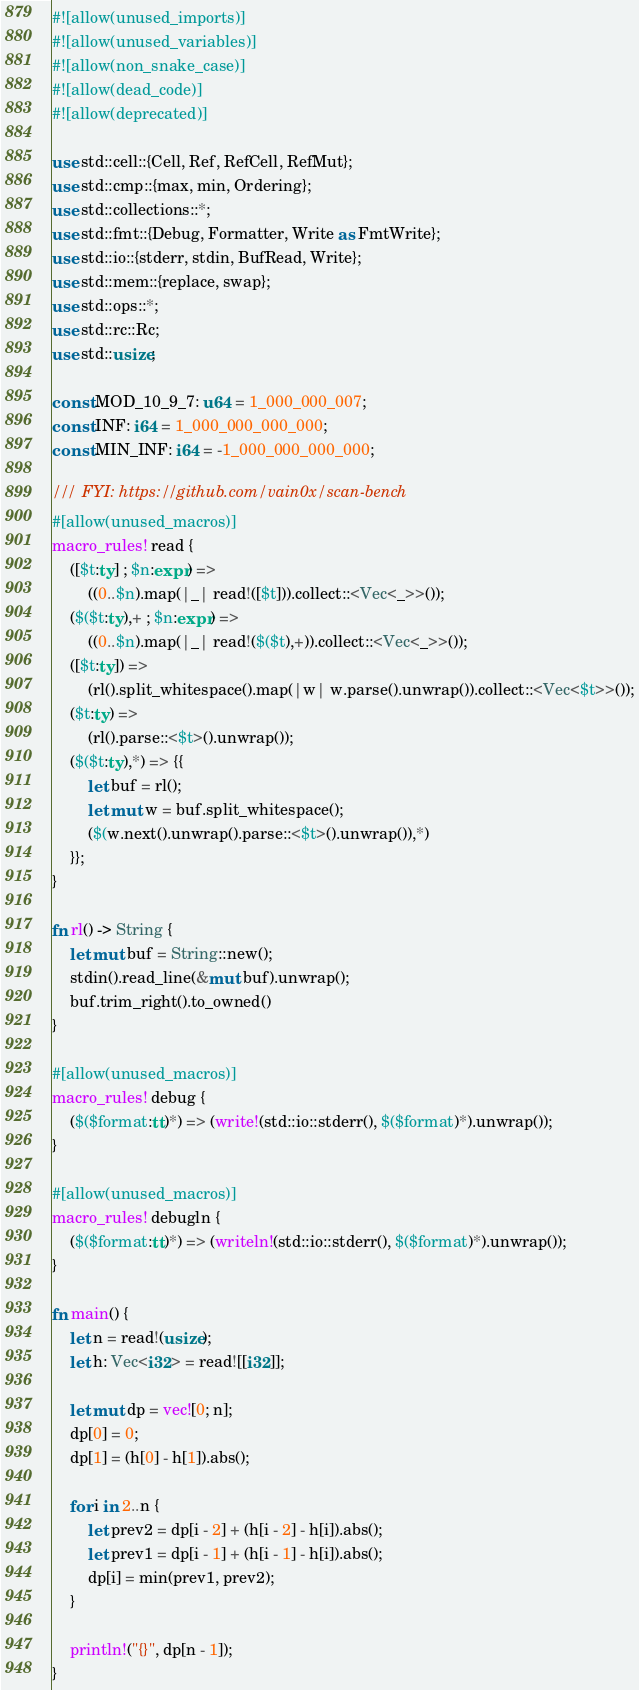<code> <loc_0><loc_0><loc_500><loc_500><_Rust_>#![allow(unused_imports)]
#![allow(unused_variables)]
#![allow(non_snake_case)]
#![allow(dead_code)]
#![allow(deprecated)]

use std::cell::{Cell, Ref, RefCell, RefMut};
use std::cmp::{max, min, Ordering};
use std::collections::*;
use std::fmt::{Debug, Formatter, Write as FmtWrite};
use std::io::{stderr, stdin, BufRead, Write};
use std::mem::{replace, swap};
use std::ops::*;
use std::rc::Rc;
use std::usize;

const MOD_10_9_7: u64 = 1_000_000_007;
const INF: i64 = 1_000_000_000_000;
const MIN_INF: i64 = -1_000_000_000_000;

/// FYI: https://github.com/vain0x/scan-bench
#[allow(unused_macros)]
macro_rules! read {
    ([$t:ty] ; $n:expr) =>
        ((0..$n).map(|_| read!([$t])).collect::<Vec<_>>());
    ($($t:ty),+ ; $n:expr) =>
        ((0..$n).map(|_| read!($($t),+)).collect::<Vec<_>>());
    ([$t:ty]) =>
        (rl().split_whitespace().map(|w| w.parse().unwrap()).collect::<Vec<$t>>());
    ($t:ty) =>
        (rl().parse::<$t>().unwrap());
    ($($t:ty),*) => {{
        let buf = rl();
        let mut w = buf.split_whitespace();
        ($(w.next().unwrap().parse::<$t>().unwrap()),*)
    }};
}

fn rl() -> String {
    let mut buf = String::new();
    stdin().read_line(&mut buf).unwrap();
    buf.trim_right().to_owned()
}

#[allow(unused_macros)]
macro_rules! debug {
    ($($format:tt)*) => (write!(std::io::stderr(), $($format)*).unwrap());
}

#[allow(unused_macros)]
macro_rules! debugln {
    ($($format:tt)*) => (writeln!(std::io::stderr(), $($format)*).unwrap());
}

fn main() {
    let n = read!(usize);
    let h: Vec<i32> = read![[i32]];

    let mut dp = vec![0; n];
    dp[0] = 0;
    dp[1] = (h[0] - h[1]).abs();

    for i in 2..n {
        let prev2 = dp[i - 2] + (h[i - 2] - h[i]).abs();
        let prev1 = dp[i - 1] + (h[i - 1] - h[i]).abs();
        dp[i] = min(prev1, prev2);
    }

    println!("{}", dp[n - 1]);
}
</code> 